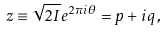Convert formula to latex. <formula><loc_0><loc_0><loc_500><loc_500>z \equiv \sqrt { 2 I } e ^ { 2 \pi i \theta } = p + i q \, ,</formula> 